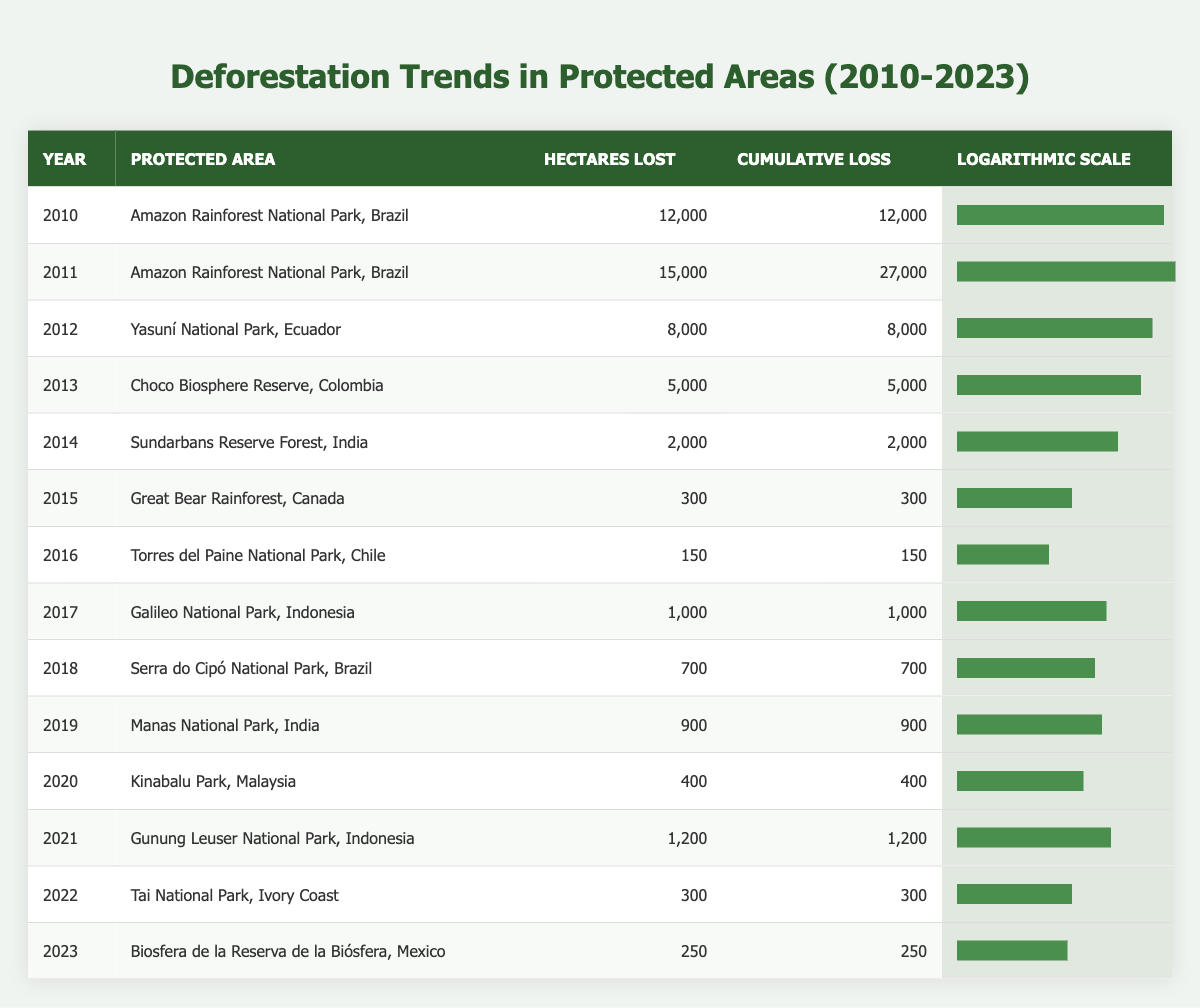What was the total area lost in the Amazon Rainforest National Park in 2011? The table shows that in 2011, the area lost in the Amazon Rainforest National Park was 15,000 hectares.
Answer: 15,000 hectares Which protected area had the lowest hectares lost in a single year? According to the table, the Great Bear Rainforest in Canada had the lowest hectares lost in a single year, which was 300 hectares in 2015.
Answer: 300 hectares What is the cumulative loss of the Yasuní National Park by the end of 2012? The table indicates that the cumulative loss by the end of 2012 for Yasuní National Park was 8,000 hectares, as it is the only year recorded for that park.
Answer: 8,000 hectares How many hectares were lost in total from 2010 to 2021 in the Amazon Rainforest National Park? From 2010 to 2011 in the Amazon Rainforest National Park, a total of 12,000 hectares (2010) + 15,000 hectares (2011) = 27,000 hectares were lost. No other years are listed for this park from 2010 to 2021.
Answer: 27,000 hectares Was there any year where the hectares lost in protected areas exceeded 10,000 hectares? Yes, the years 2010 and 2011 in the Amazon Rainforest National Park both exceeded 10,000 hectares lost, with 12,000 and 15,000 hectares respectively.
Answer: Yes What is the average hectares lost per year at the Torres del Paine National Park from 2016 to 2023? The table shows that for Torres del Paine National Park in 2016, 150 hectares were lost. Since this is the only year listed for this park, the average is simply 150 hectares.
Answer: 150 hectares In which year did the highest cumulative loss occur, and what was that figure? The highest cumulative loss occurred in 2011, reaching a total of 27,000 hectares, combining the losses of that year with 2010 in the Amazon Rainforest National Park.
Answer: 27,000 hectares Which park had a cumulative loss under 1,000 hectares by the end of its recorded years? The Great Bear Rainforest in Canada had a cumulative loss of only 300 hectares by the end of 2015, which is under 1,000 hectares.
Answer: Great Bear Rainforest, Canada What was the percentage increase in hectares lost from 2018 to 2019 in Manas National Park? In 2018, Manas National Park lost 700 hectares, and in 2019, it lost 900 hectares. The increase is 900 - 700 = 200 hectares, which is approximately a 28.57% increase (200/700*100).
Answer: 28.57% 